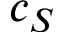<formula> <loc_0><loc_0><loc_500><loc_500>c _ { S }</formula> 